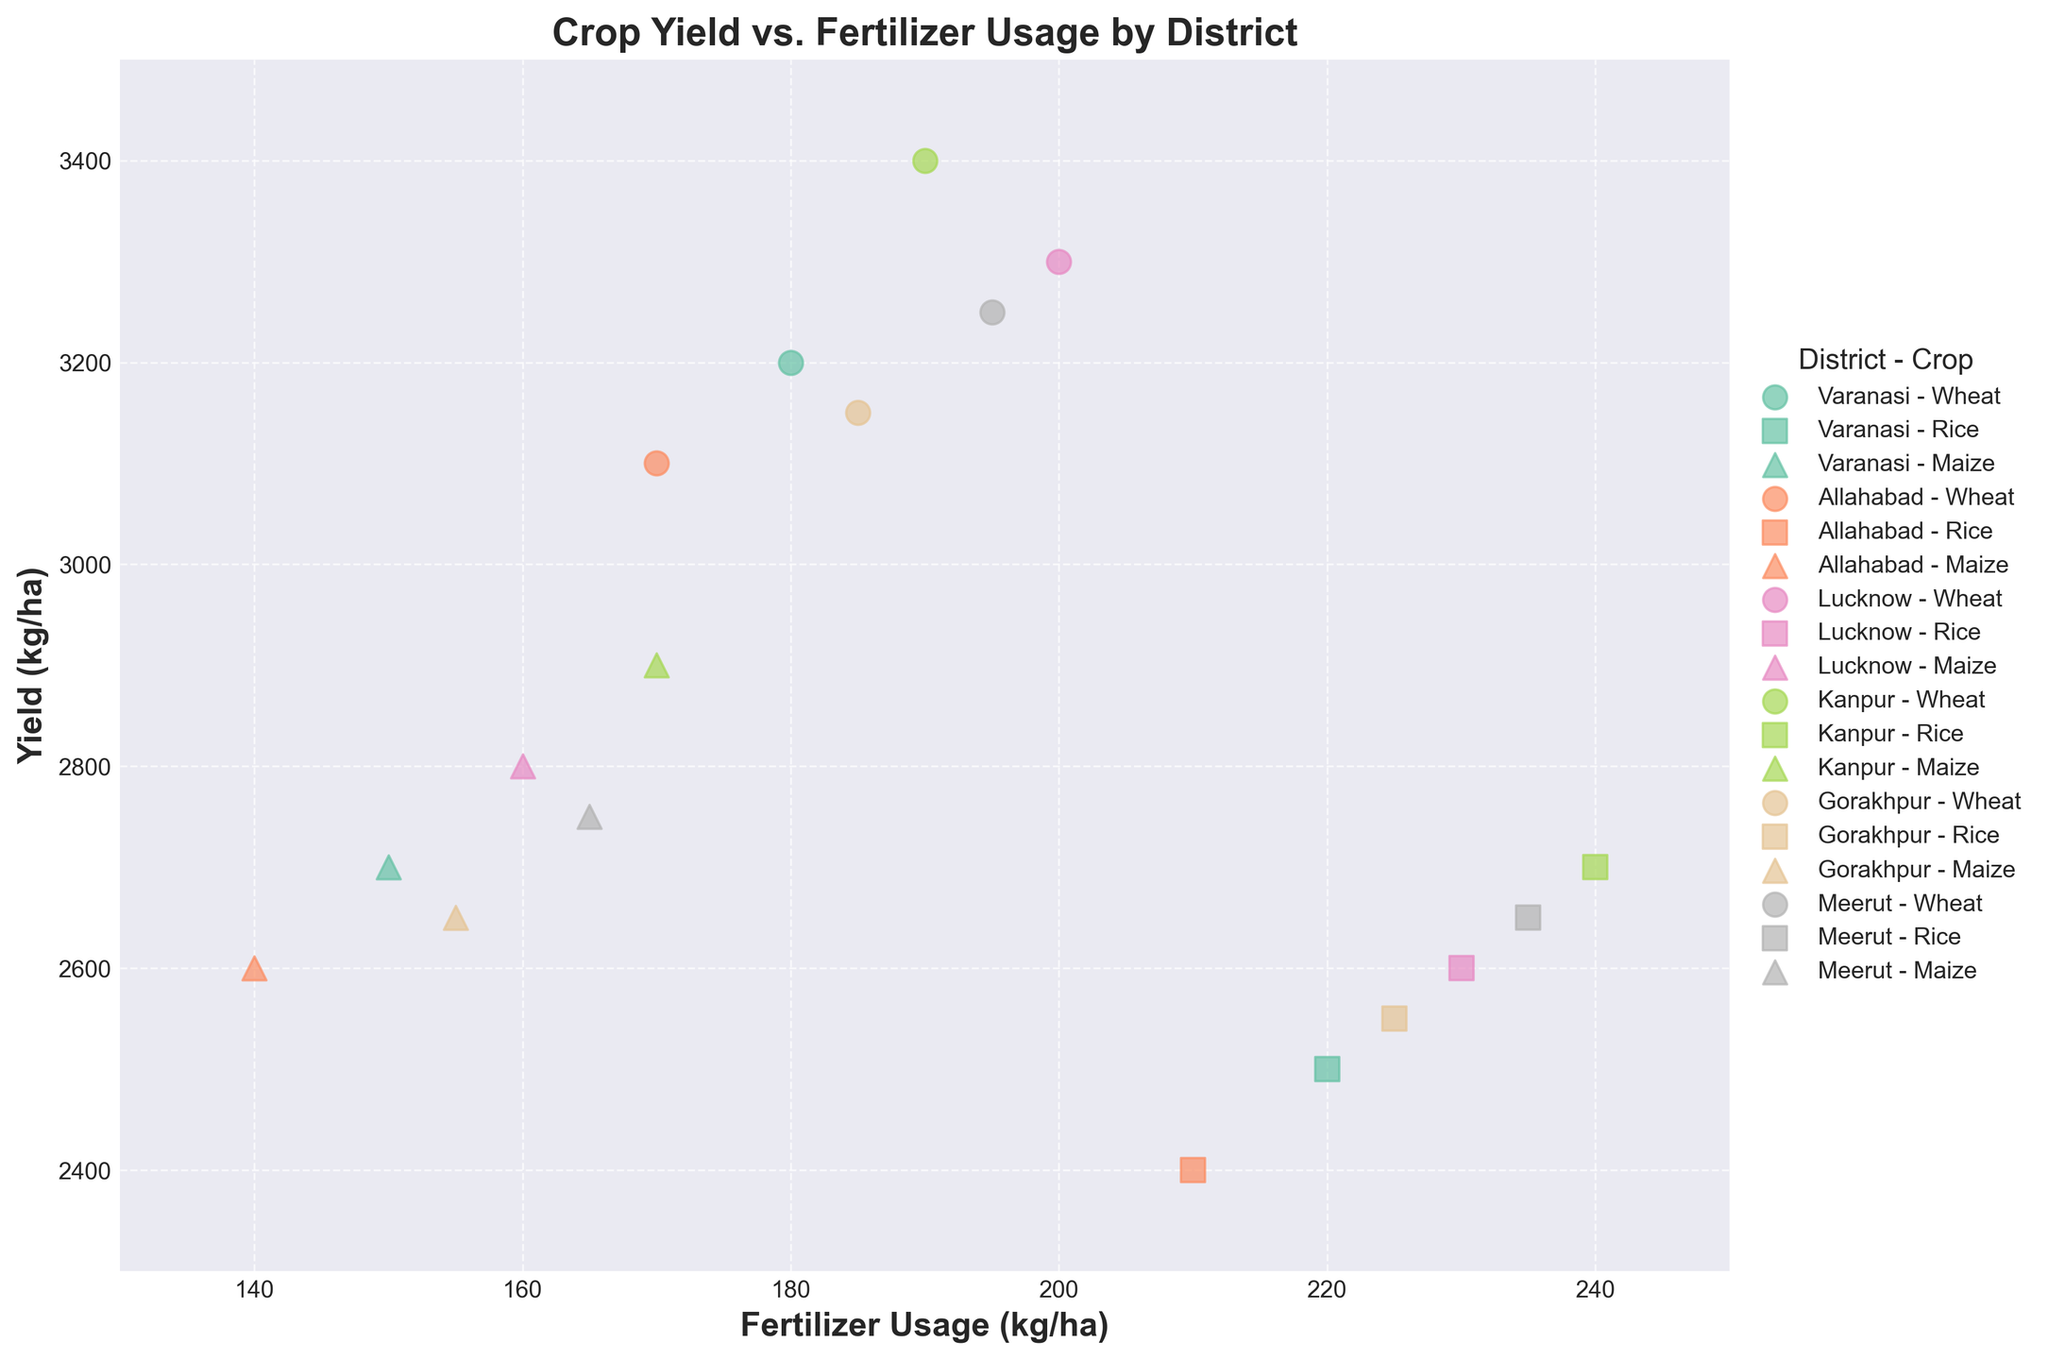What is the title of the figure? The title of the figure is often placed at the top. Referring to the plot, the title is "Crop Yield vs. Fertilizer Usage by District".
Answer: Crop Yield vs. Fertilizer Usage by District How many different districts are represented in the plot? The legend of the plot shows a list of combinations of districts and crops; by identifying unique districts here, we can count them and find they are Varanasi, Allahabad, Lucknow, Kanpur, Gorakhpur, and Meerut.
Answer: 6 Which crop in Kanpur has the highest yield? In the plot, locate 'Kanpur' in the legend to identify the markers for each crop. The highest point on the y-axis among the markers for Kanpur corresponds to the highest yield, which is for Wheat.
Answer: Wheat Is the fertilizer usage for Rice generally higher than for Maize? Comparing the markers for Rice and Maize across all districts in the scatter plot shows that Rice data points have higher values on the x-axis (fertilizer usage), indicating generally higher fertilizer usage for Rice.
Answer: Yes Which district has the lowest yield for Rice? Locate the markers in the legend for Rice. The point with the lowest value on the y-axis (yield) for these markers corresponds to Allahabad.
Answer: Allahabad What is the yield difference between Wheat and Maize in Gorakhpur? Locate and compare the y-axis values (yield) for Wheat and Maize in Gorakhpur. For Wheat, it is 3150 kg/ha, and for Maize, it is 2650 kg/ha. The difference is 3150 - 2650 = 500.
Answer: 500 Does Meerut use more fertilizer for Rice or for Wheat? Locate the markers in the legend representing Meerut for Rice and Wheat. Compare their x-axis values (fertilizer usage). For Rice, it is 235 kg/ha, and for Wheat, it is 195 kg/ha. So, more fertilizer is used for Rice.
Answer: Rice Which crop in Varanasi has the smallest fertilizer usage? Refer to the legend and plot for Varanasi and check the x-axis values (fertilizer usage). Maize has the lowest fertilizer usage (150 kg/ha) among the crops.
Answer: Maize What is the average yield for Wheat across all districts? Locate the yield values for Wheat in all districts: 3200, 3100, 3300, 3400, 3150, and 3250 kg/ha. Sum them up: 3200 + 3100 + 3300 + 3400 + 3150 + 3250 = 19200, then divide by the number of districts (6). The average yield is 19200 / 6 = 3200.
Answer: 3200 